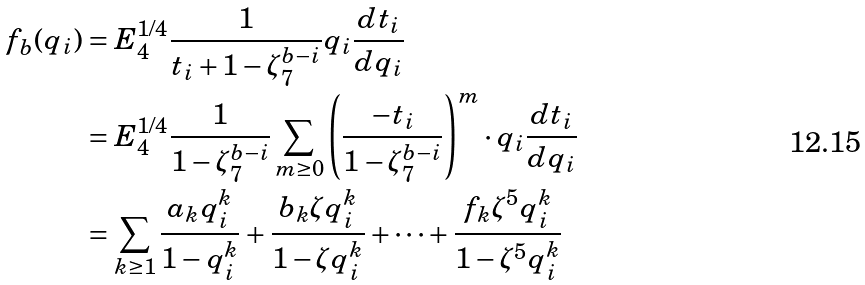<formula> <loc_0><loc_0><loc_500><loc_500>f _ { b } ( q _ { i } ) & = E _ { 4 } ^ { 1 / 4 } \frac { 1 } { t _ { i } + 1 - \zeta _ { 7 } ^ { b - i } } q _ { i } \frac { d t _ { i } } { d q _ { i } } \\ & = E _ { 4 } ^ { 1 / 4 } \frac { 1 } { 1 - \zeta _ { 7 } ^ { b - i } } \sum _ { m \geq 0 } \left ( \frac { - t _ { i } } { 1 - \zeta _ { 7 } ^ { b - i } } \right ) ^ { m } \cdot q _ { i } \frac { d t _ { i } } { d q _ { i } } \\ & = \sum _ { k \geq 1 } \frac { a _ { k } q _ { i } ^ { k } } { 1 - q _ { i } ^ { k } } + \frac { b _ { k } \zeta q _ { i } ^ { k } } { 1 - \zeta q _ { i } ^ { k } } + \cdots + \frac { f _ { k } \zeta ^ { 5 } q _ { i } ^ { k } } { 1 - \zeta ^ { 5 } q _ { i } ^ { k } }</formula> 